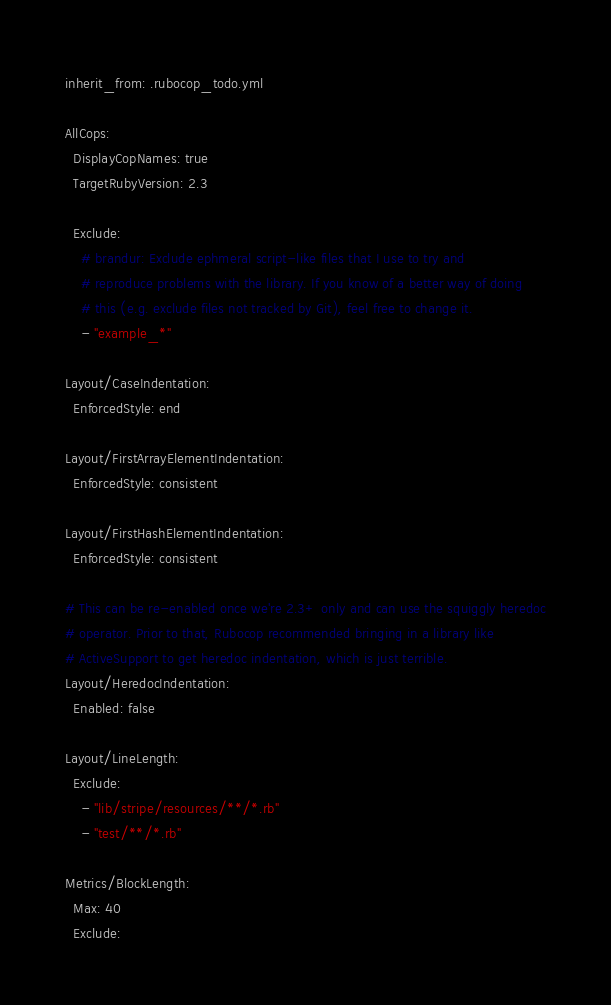<code> <loc_0><loc_0><loc_500><loc_500><_YAML_>inherit_from: .rubocop_todo.yml

AllCops:
  DisplayCopNames: true
  TargetRubyVersion: 2.3

  Exclude:
    # brandur: Exclude ephmeral script-like files that I use to try and
    # reproduce problems with the library. If you know of a better way of doing
    # this (e.g. exclude files not tracked by Git), feel free to change it.
    - "example_*"

Layout/CaseIndentation:
  EnforcedStyle: end

Layout/FirstArrayElementIndentation:
  EnforcedStyle: consistent

Layout/FirstHashElementIndentation:
  EnforcedStyle: consistent

# This can be re-enabled once we're 2.3+ only and can use the squiggly heredoc
# operator. Prior to that, Rubocop recommended bringing in a library like
# ActiveSupport to get heredoc indentation, which is just terrible.
Layout/HeredocIndentation:
  Enabled: false

Layout/LineLength:
  Exclude:
    - "lib/stripe/resources/**/*.rb"
    - "test/**/*.rb"

Metrics/BlockLength:
  Max: 40
  Exclude:</code> 